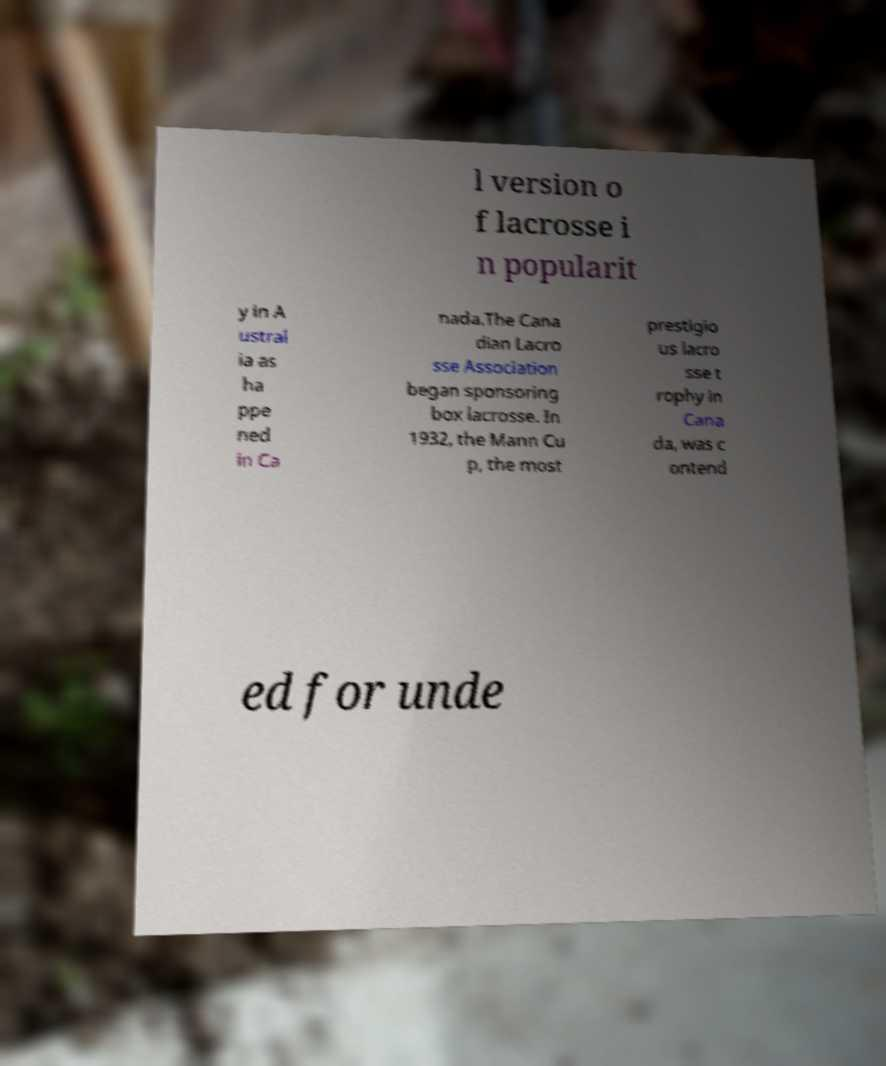I need the written content from this picture converted into text. Can you do that? l version o f lacrosse i n popularit y in A ustral ia as ha ppe ned in Ca nada.The Cana dian Lacro sse Association began sponsoring box lacrosse. In 1932, the Mann Cu p, the most prestigio us lacro sse t rophy in Cana da, was c ontend ed for unde 